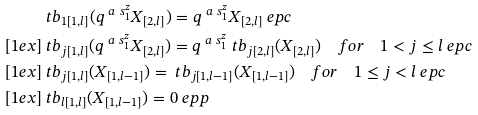<formula> <loc_0><loc_0><loc_500><loc_500>& \ t b _ { 1 [ 1 , l ] } ( q ^ { \ a \ s ^ { z } _ { 1 } } X _ { [ 2 , l ] } ) = q ^ { \ a \ s ^ { z } _ { 1 } } X _ { [ 2 , l ] } \ e p c \\ [ 1 e x ] & \ t b _ { j [ 1 , l ] } ( q ^ { \ a \ s ^ { z } _ { 1 } } X _ { [ 2 , l ] } ) = q ^ { \ a \ s ^ { z } _ { 1 } } \ t b _ { j [ 2 , l ] } ( X _ { [ 2 , l ] } ) \quad f o r \quad 1 < j \leq l \ e p c \\ [ 1 e x ] & \ t b _ { j [ 1 , l ] } ( X _ { [ 1 , l - 1 ] } ) = \ t b _ { j [ 1 , l - 1 ] } ( X _ { [ 1 , l - 1 ] } ) \quad f o r \quad 1 \leq j < l \ e p c \\ [ 1 e x ] & \ t b _ { l [ 1 , l ] } ( X _ { [ 1 , l - 1 ] } ) = 0 \ e p p</formula> 